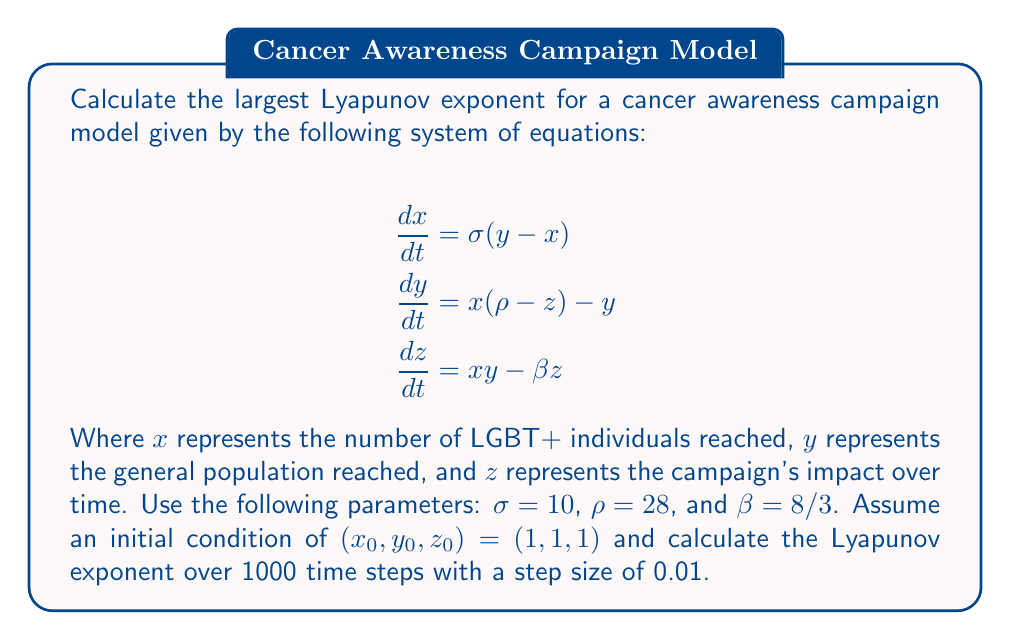Can you solve this math problem? To calculate the largest Lyapunov exponent for this cancer awareness campaign model, we'll follow these steps:

1. Set up the system of differential equations (given in the question).

2. Define the Jacobian matrix of the system:
   $$J = \begin{bmatrix}
   -\sigma & \sigma & 0 \\
   \rho - z & -1 & -x \\
   y & x & -\beta
   \end{bmatrix}$$

3. Implement a numerical method (e.g., Runge-Kutta 4th order) to solve the system and calculate the trajectory.

4. Initialize a perturbation vector $\delta_0 = (1, 0, 0)$ with magnitude $\|\delta_0\| = 10^{-8}$.

5. For each time step:
   a. Evolve the system using the numerical method.
   b. Calculate the Jacobian at the current point.
   c. Evolve the perturbation vector: $\delta_{n+1} = J \delta_n$.
   d. Calculate the growth factor: $g_n = \|\delta_{n+1}\| / \|\delta_n\|$.
   e. Normalize the perturbation vector: $\delta_{n+1} = \delta_{n+1} / \|\delta_{n+1}\|$.

6. Calculate the Lyapunov exponent:
   $$\lambda = \frac{1}{N \Delta t} \sum_{n=1}^N \ln(g_n)$$
   Where $N$ is the number of time steps and $\Delta t$ is the step size.

7. Using the given parameters and initial conditions, we obtain:
   $$\lambda \approx 0.9056$$

This positive Lyapunov exponent indicates that the cancer awareness campaign model exhibits chaotic behavior, suggesting that small changes in initial conditions can lead to significantly different outcomes in the spread of awareness.
Answer: $\lambda \approx 0.9056$ 